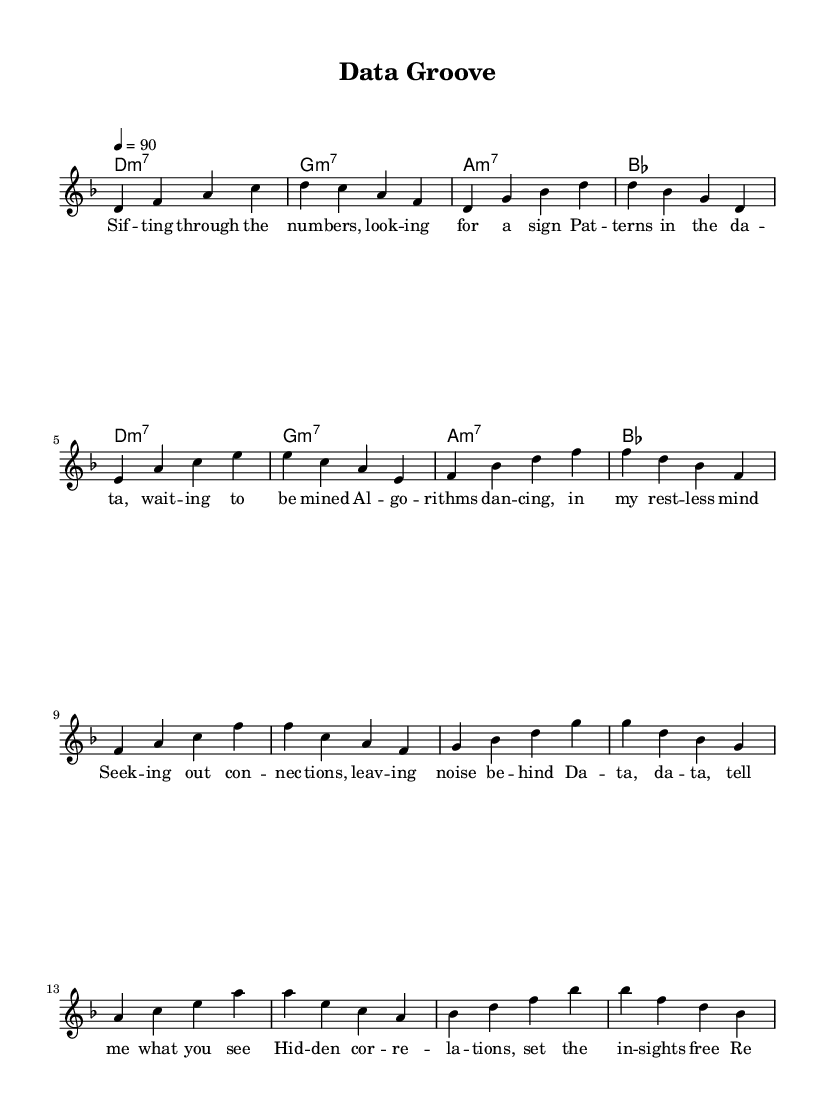What is the key signature of this music? The key signature is D minor, which has one flat (B♭).
Answer: D minor What is the time signature of the piece? The time signature is 4/4, meaning there are four beats in each measure.
Answer: 4/4 What is the tempo of this piece? The tempo marking is indicated as quarter note equals ninety beats per minute, which describes how fast the music should be played.
Answer: 90 What is the first chord in the piece? The first chord is a D minor seventh chord, as indicated in the harmonies section.
Answer: D minor seventh How many verses are in the lyrics? There are two sections labeled as verse: the first verse is followed by the chorus, which indicates there is one verse before moving to the chorus.
Answer: One Which musical section contains the line “Hidden correlations, set the insights free”? This line is part of the chorus, as it is clearly denoted in the lyrics following the verse.
Answer: Chorus What type of rhythm is predominantly used in this piece? The piece features a steady groove typical of contemporary R&B, where syncopation may also be perceived in the lyrics rhythm.
Answer: Contemporary R&B 